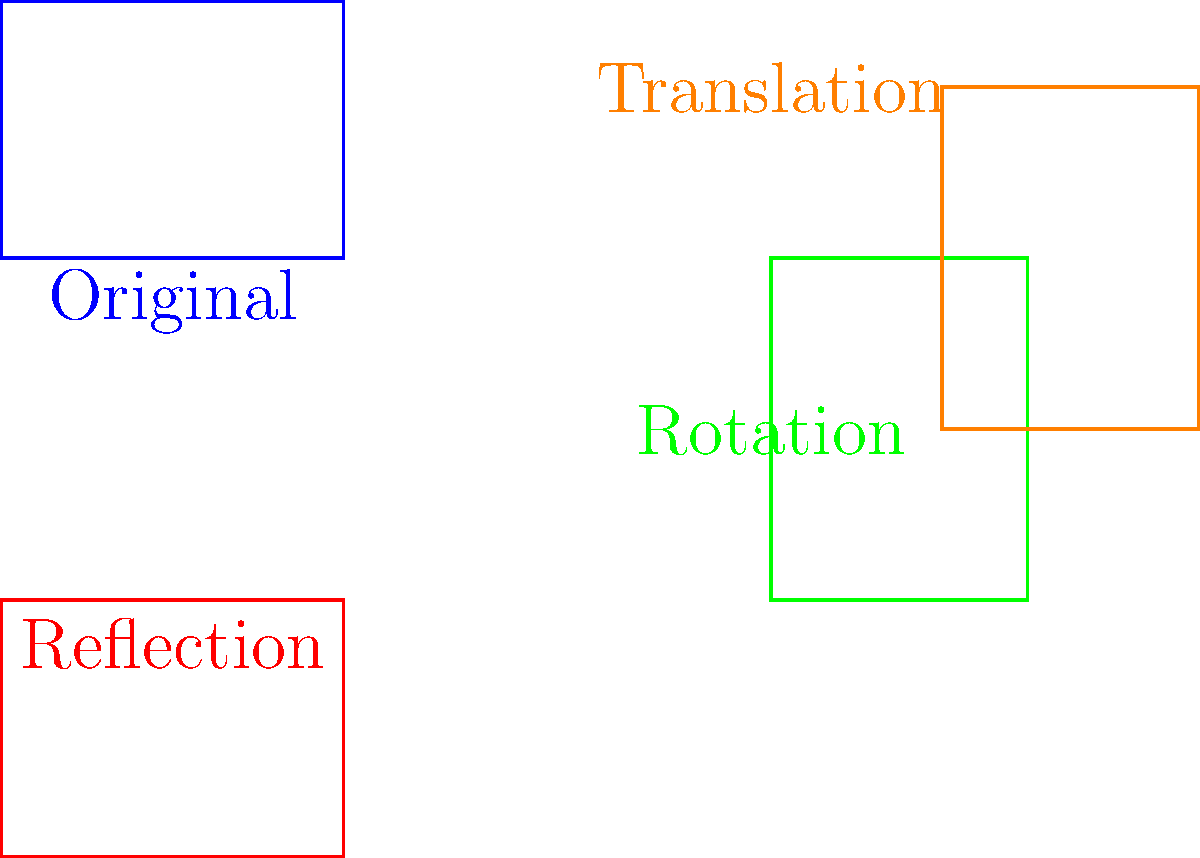The logo of a local Bradley Stoke business undergoes a series of transformations. Starting from the original blue rectangle, it is first reflected over the x-axis, then rotated 90° clockwise around the point (4,0), and finally translated 2 units right and 2 units up. What is the total vertical displacement of point D from its original position to its final position after all transformations? Let's follow the transformations step by step:

1. Original position of point D: (0,3)

2. Reflection over x-axis:
   - y-coordinate changes sign
   - New position: (0,-3)
   - Vertical displacement so far: 3 - (-3) = 6 units down

3. Rotation 90° clockwise around (4,0):
   - Relative to (4,0), D is at (-4,-3)
   - After rotation, it's at (4,-1)
   - Vertical displacement: -1 - (-3) = 2 units up

4. Translation 2 units right and 2 units up:
   - New position: (6,1)
   - Vertical displacement: 2 units up

Total vertical displacement:
$$6 \text{ (down) } + 2 \text{ (up) } + 2 \text{ (up) } = 2 \text{ units down}$$

The point D starts at y = 3 and ends at y = 1, confirming a total displacement of 2 units down.
Answer: 2 units down 